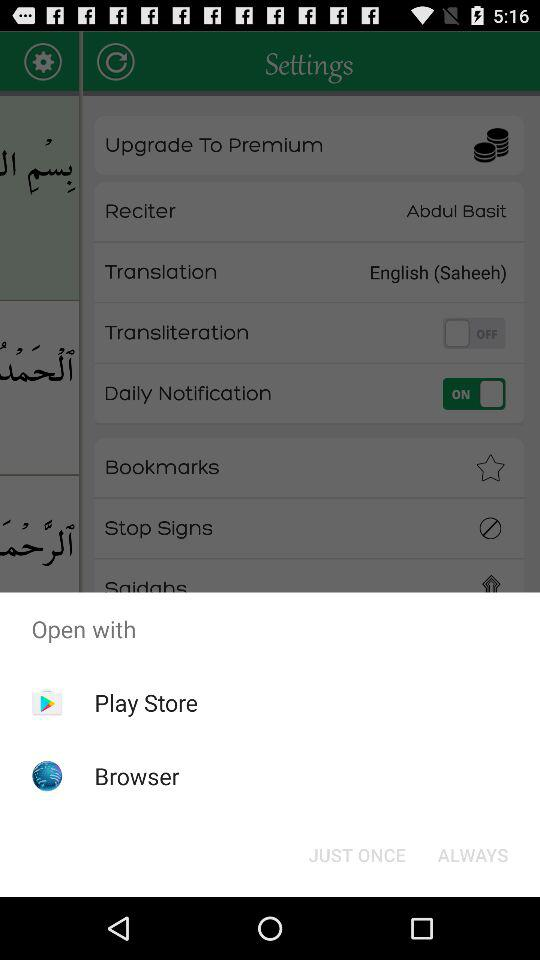What is the status of "Daily Notification"? The status is "on". 